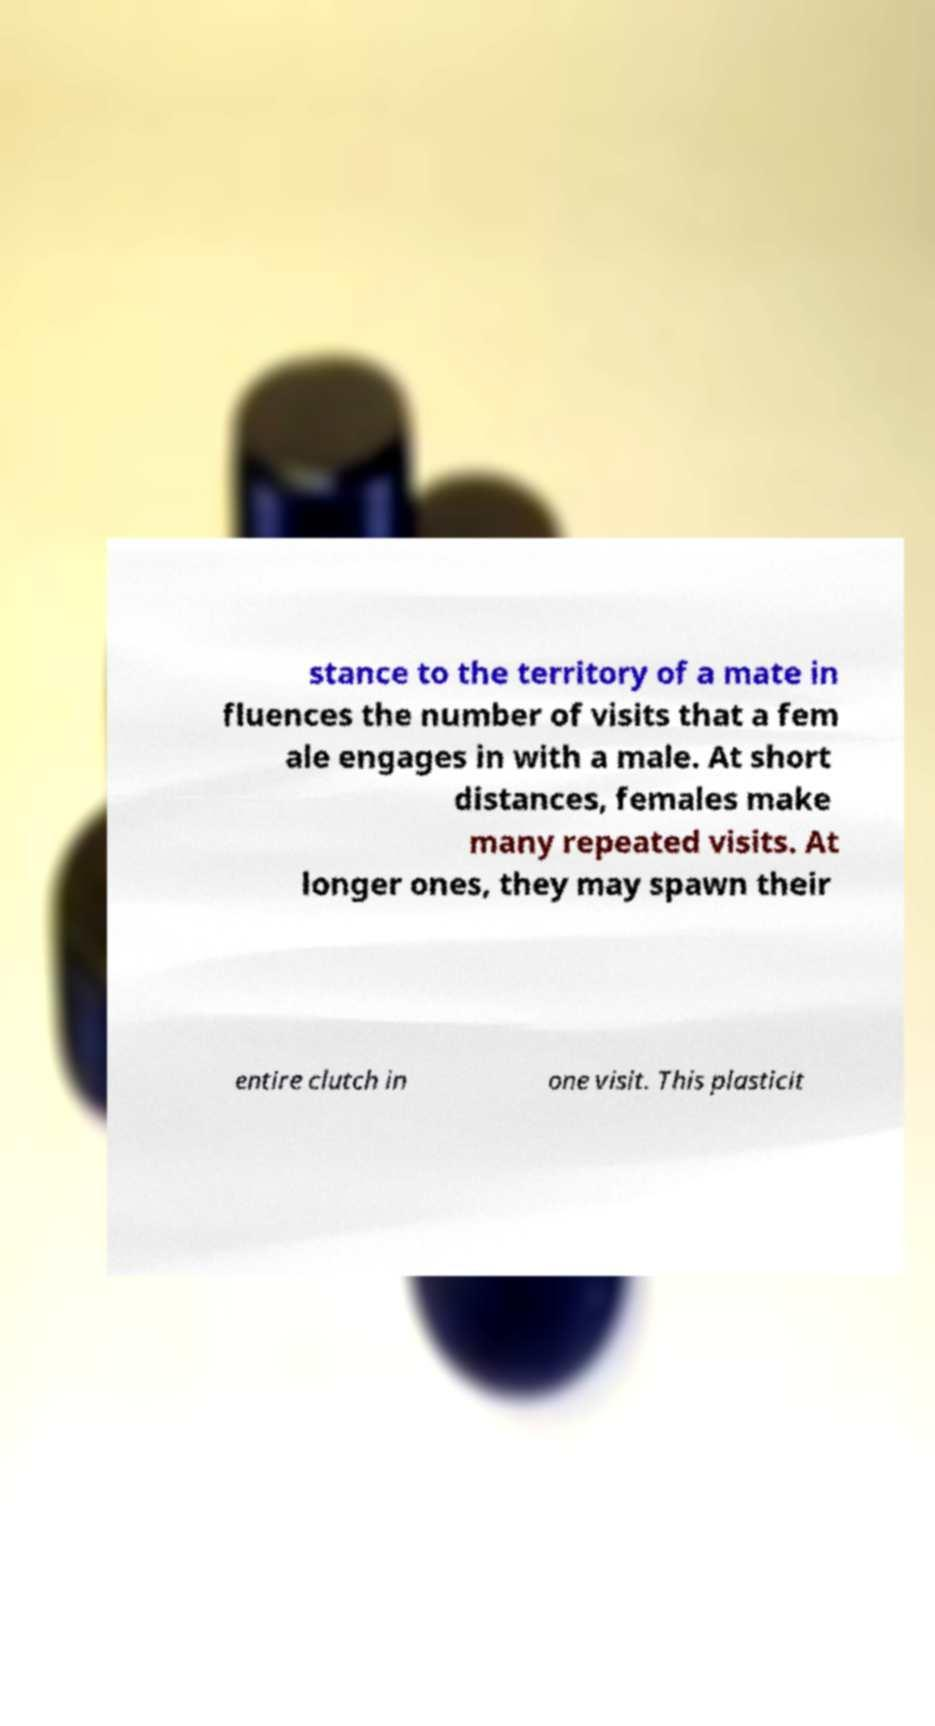Can you accurately transcribe the text from the provided image for me? stance to the territory of a mate in fluences the number of visits that a fem ale engages in with a male. At short distances, females make many repeated visits. At longer ones, they may spawn their entire clutch in one visit. This plasticit 